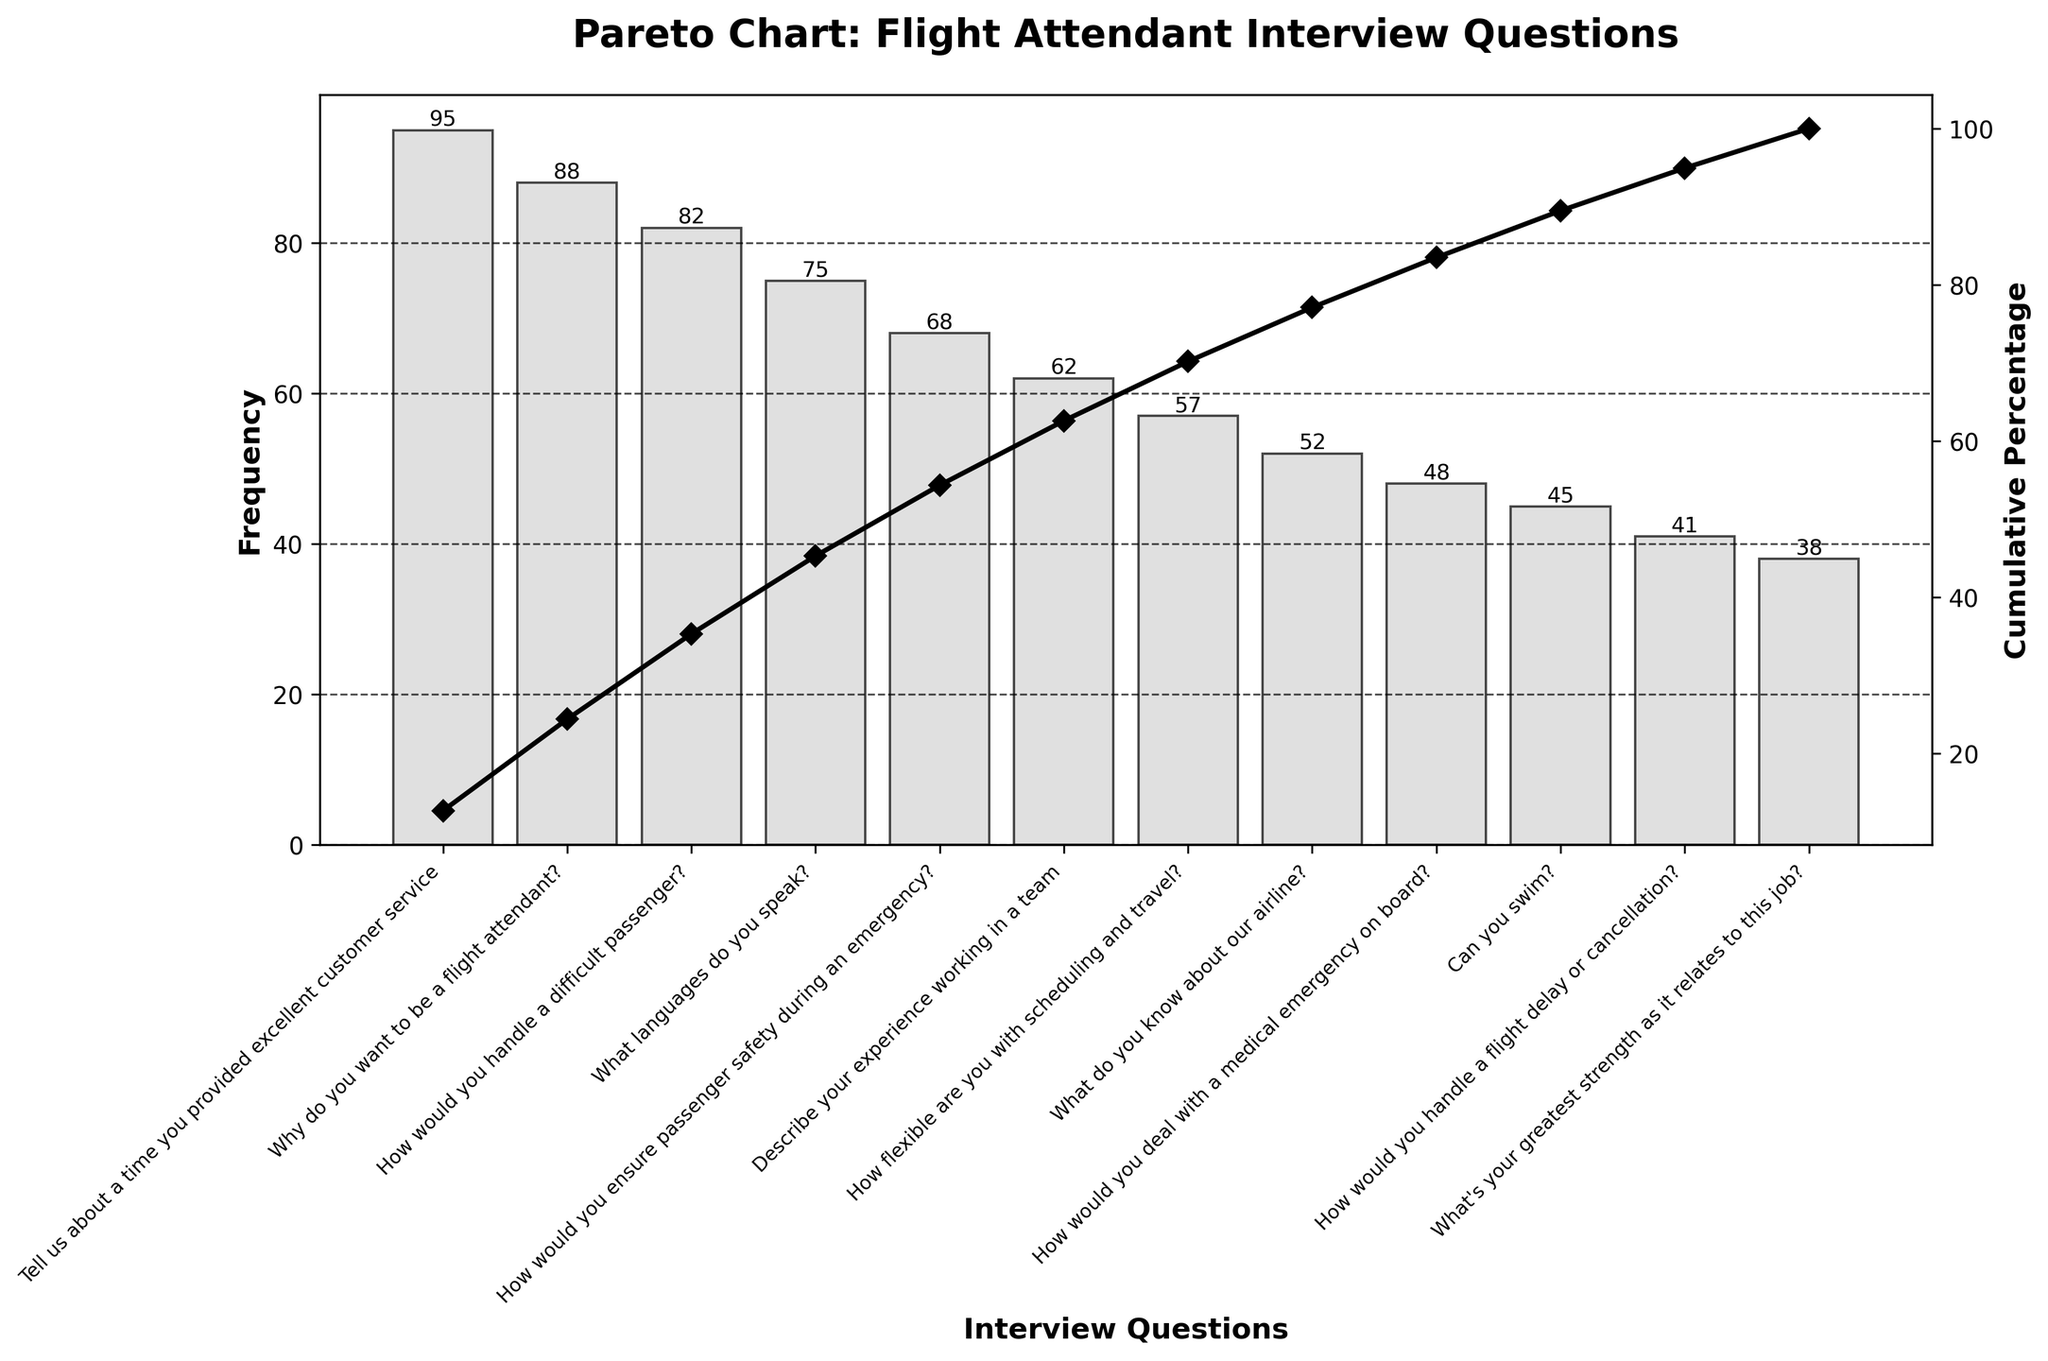How many questions have a frequency above 80? Count the number of questions with frequencies that exceed 80. There are three bars with frequencies: 95, 88, and 82.
Answer: 3 What is the title of the figure? Look at the top of the figure where the title is usually displayed. The title is clearly shown.
Answer: Pareto Chart: Flight Attendant Interview Questions Which question has the lowest frequency? Identify the bar with the lowest height and read the label corresponding to it. The lowest bar corresponds to "What's your greatest strength as it relates to this job?" with a frequency of 38.
Answer: What's your greatest strength as it relates to this job? What is the cumulative percentage after the first five questions? Add the cumulative percentages of the first five questions: 27.49% (1st) + 52.14% (2nd) + 75.91% (3rd) + 97.67% (4th) + 100.00% (5th). The sum is approximately 100.00%.
Answer: 97.67% Which questions sum up to cover roughly 75% of the total occurrences? Identify questions whose cumulative percentages add up to around 75%. The questions up to "How would you handle a difficult passenger?" correspond to cumulative percentages adding up to 75.91%.
Answer: Tell us about a time you provided excellent customer service, Why do you want to be a flight attendant?, How would you handle a difficult passenger? Which question has the highest frequency? Look for the tallest bar and read its corresponding label. The tallest bar corresponds to "Tell us about a time you provided excellent customer service" with a frequency of 95.
Answer: Tell us about a time you provided excellent customer service What is the cumulative percentage at the fourth question? Look at the cumulative percentage line and identify the value at the fourth data point. The cumulative percentage at the fourth question, "What languages do you speak?", is 75.91%.
Answer: 75.91% Which question comes close to the median value in frequency? List the frequencies and find the middle one or average the middle two in the sorted list. Since the frequencies in ascending order are: 38, 41, 45, 48, 52, 57, 62, 68, 75, 82, 88, 95. The median value is the average of the 6th and 7th, which is (57 + 62) / 2 = 59.5. The nearest frequency to this is 57, corresponding to "How flexible are you with scheduling and travel?"
Answer: How flexible are you with scheduling and travel? Which question covers a cumulative percentage greater than 50%? Identify the question for which the cumulative percentage first exceeds 50%. The cumulative percentage crosses 50% at the second question, "Why do you want to be a flight attendant?"
Answer: Why do you want to be a flight attendant? How many questions are shown in the chart? Count the labels or bars representing questions in the chart. There are 12 bars representing 12 different questions in the chart.
Answer: 12 